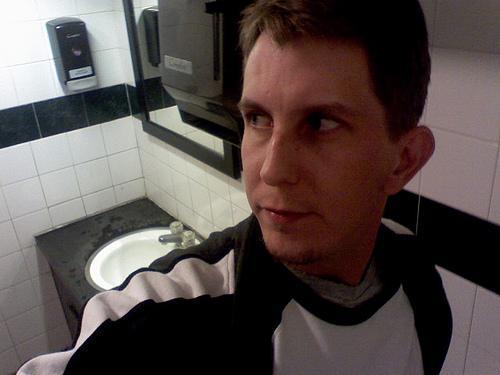How many people are there?
Give a very brief answer. 1. 